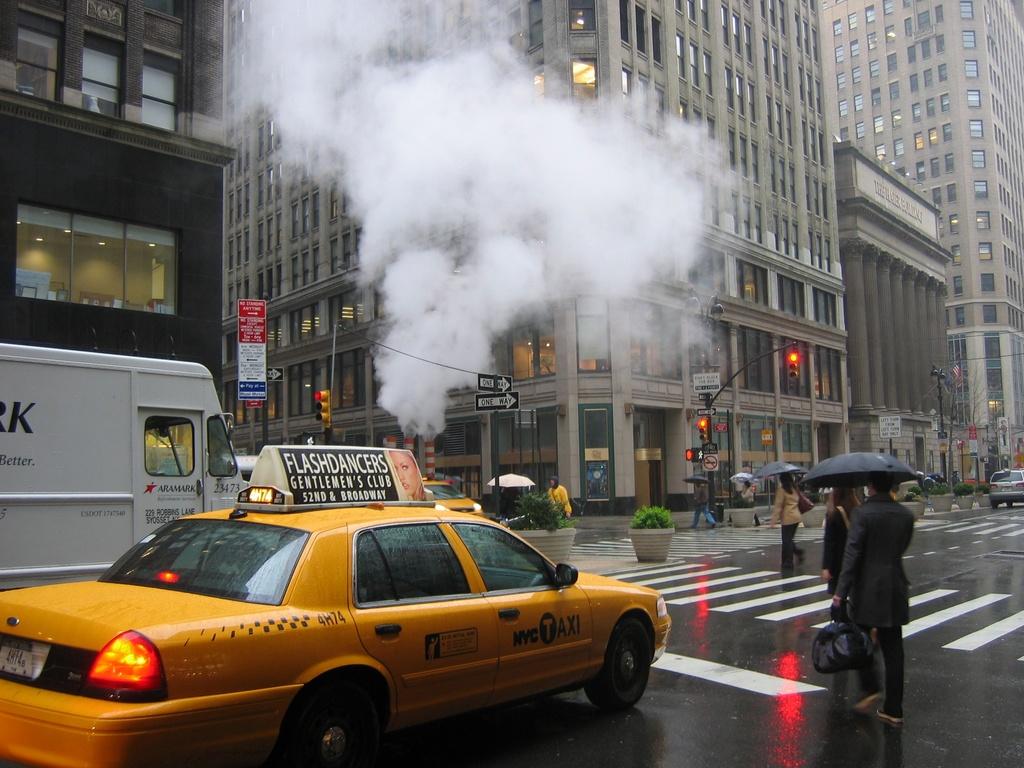What is this taxi advertising?
Ensure brevity in your answer.  Flashdancers. What number is the taxi?
Your response must be concise. 4h74. 